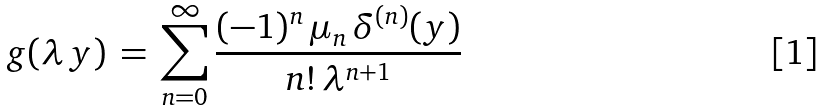<formula> <loc_0><loc_0><loc_500><loc_500>g ( \lambda \, y ) \, = \, \sum _ { n = 0 } ^ { \infty } \frac { ( - 1 ) ^ { n } \, \mu _ { n } \, \delta ^ { ( n ) } ( y ) } { n ! \, \lambda ^ { n + 1 } }</formula> 